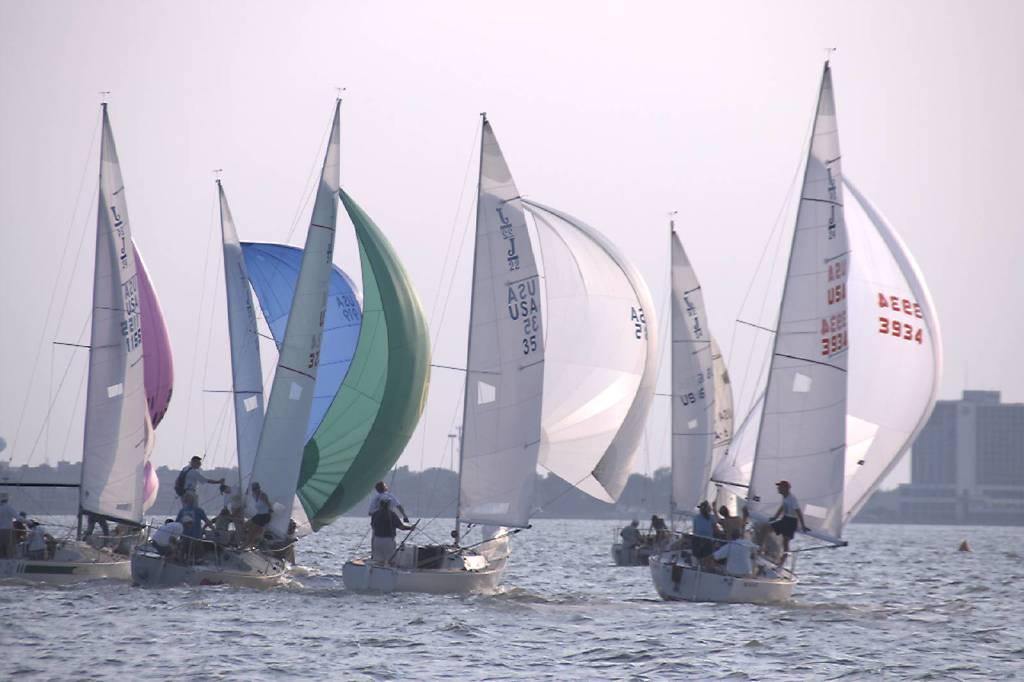What are the people in the image doing? The people in the image are on boats. What is the primary setting of the image? There is water visible in the image. What structures can be seen in the image? There are buildings in the image. What type of vegetation is visible in the background of the image? Trees are present in the background of the image. What is visible at the top of the image? The sky is visible at the top of the image. Can you see any sticks playing in harmony with the boats in the image? There are no sticks or any indication of harmony with the boats in the image. Are there any flowers visible in the image? There is no mention of flowers in the provided facts, and therefore we cannot determine if any are present in the image. 